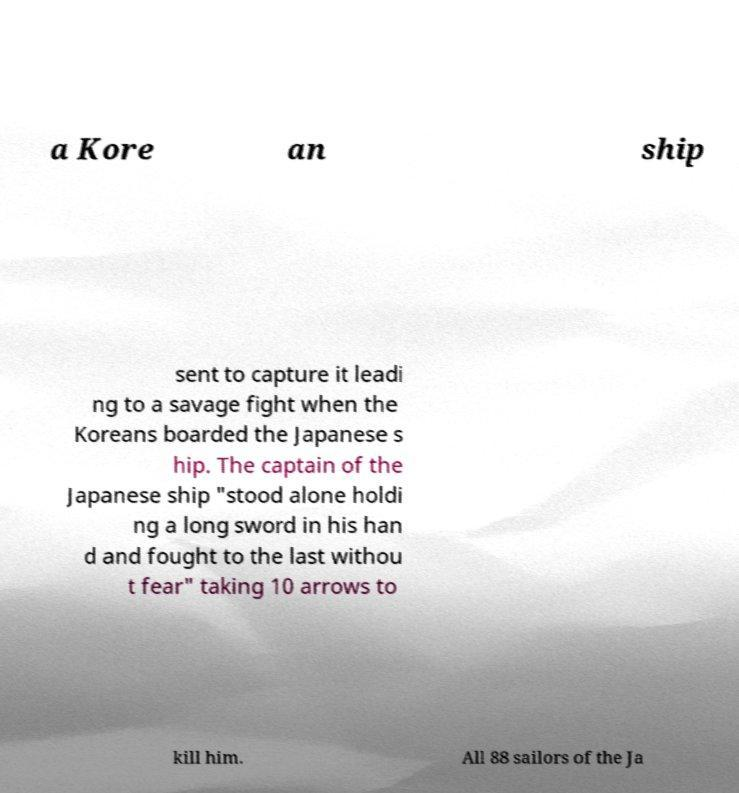For documentation purposes, I need the text within this image transcribed. Could you provide that? a Kore an ship sent to capture it leadi ng to a savage fight when the Koreans boarded the Japanese s hip. The captain of the Japanese ship "stood alone holdi ng a long sword in his han d and fought to the last withou t fear" taking 10 arrows to kill him. All 88 sailors of the Ja 